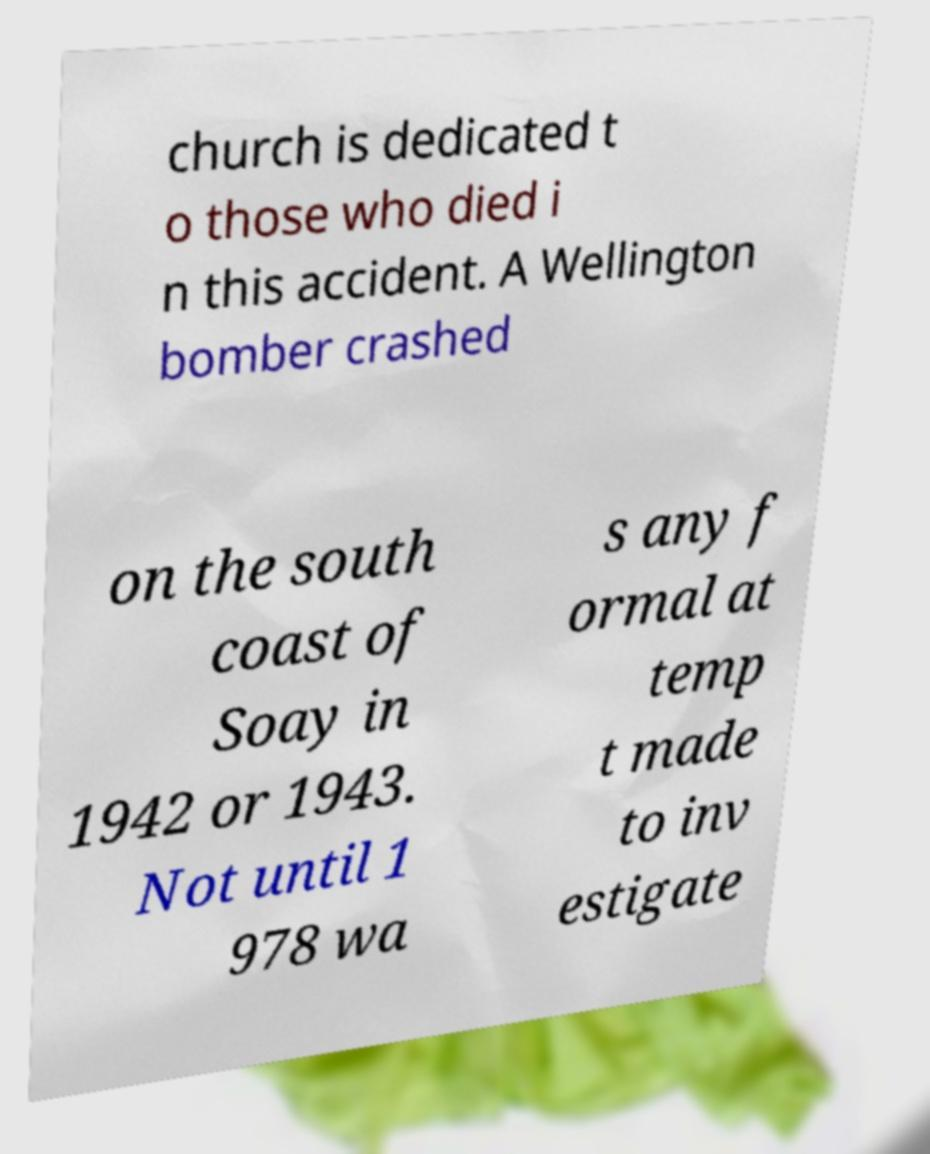Please identify and transcribe the text found in this image. church is dedicated t o those who died i n this accident. A Wellington bomber crashed on the south coast of Soay in 1942 or 1943. Not until 1 978 wa s any f ormal at temp t made to inv estigate 